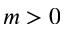Convert formula to latex. <formula><loc_0><loc_0><loc_500><loc_500>m > 0</formula> 